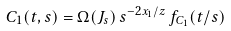<formula> <loc_0><loc_0><loc_500><loc_500>C _ { 1 } ( t , s ) = \Omega ( J _ { s } ) \, s ^ { - 2 x _ { 1 } / z } \, f _ { C _ { 1 } } ( t / s )</formula> 